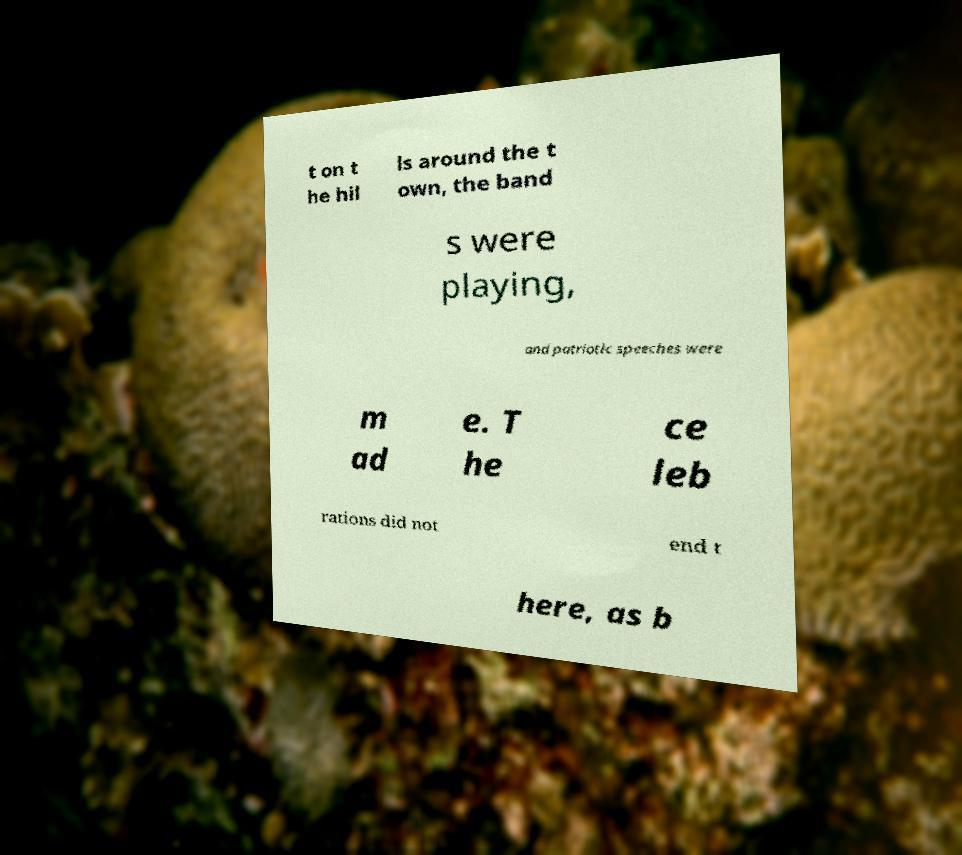Please identify and transcribe the text found in this image. t on t he hil ls around the t own, the band s were playing, and patriotic speeches were m ad e. T he ce leb rations did not end t here, as b 